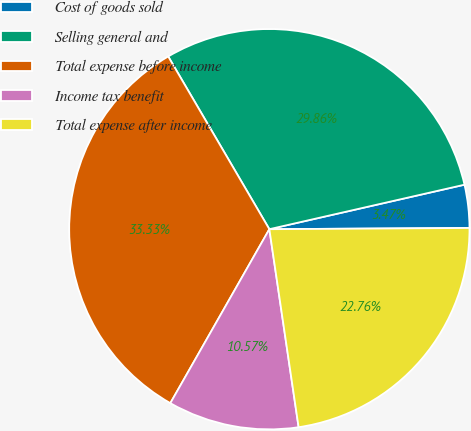<chart> <loc_0><loc_0><loc_500><loc_500><pie_chart><fcel>Cost of goods sold<fcel>Selling general and<fcel>Total expense before income<fcel>Income tax benefit<fcel>Total expense after income<nl><fcel>3.47%<fcel>29.86%<fcel>33.33%<fcel>10.57%<fcel>22.76%<nl></chart> 